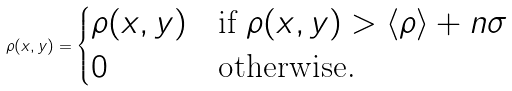Convert formula to latex. <formula><loc_0><loc_0><loc_500><loc_500>\rho ( x , y ) = \begin{cases} \rho ( x , y ) & \text {if } \rho ( x , y ) > \langle \rho \rangle + n \sigma \\ 0 & \text {otherwise.} \end{cases}</formula> 